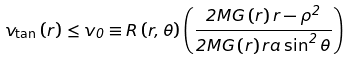<formula> <loc_0><loc_0><loc_500><loc_500>v _ { \text {tan} } \left ( r \right ) \leq v _ { 0 } \equiv R \left ( r , \theta \right ) \left ( \frac { 2 M G \left ( r \right ) r - \rho ^ { 2 } } { 2 M G \left ( r \right ) r a \sin ^ { 2 } \theta } \right )</formula> 